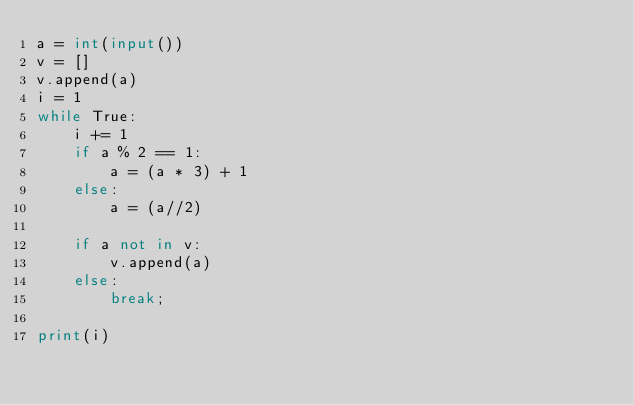<code> <loc_0><loc_0><loc_500><loc_500><_Python_>a = int(input())
v = []
v.append(a)
i = 1
while True:
    i += 1
    if a % 2 == 1:
        a = (a * 3) + 1  
    else:
        a = (a//2)

    if a not in v:
        v.append(a)
    else:
        break;

print(i)</code> 